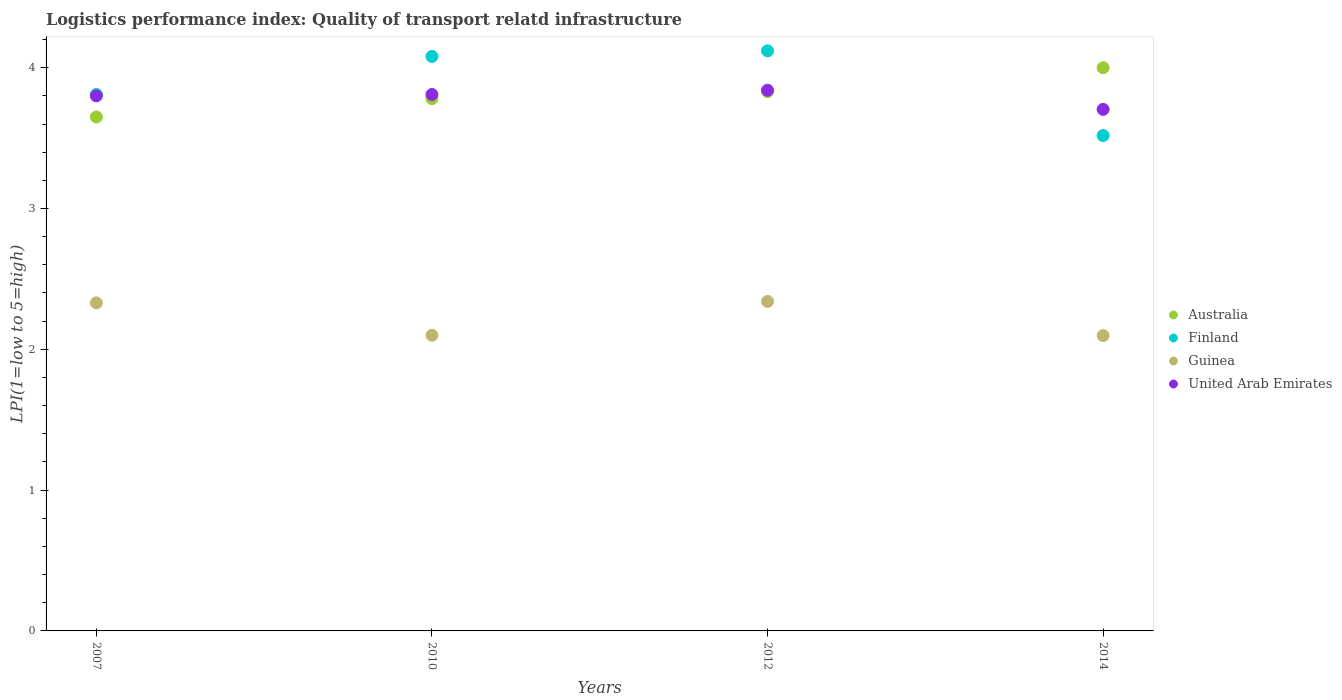What is the logistics performance index in Guinea in 2012?
Give a very brief answer. 2.34. Across all years, what is the maximum logistics performance index in Guinea?
Offer a very short reply. 2.34. Across all years, what is the minimum logistics performance index in Australia?
Ensure brevity in your answer.  3.65. What is the total logistics performance index in Australia in the graph?
Offer a terse response. 15.26. What is the difference between the logistics performance index in Guinea in 2007 and that in 2012?
Offer a terse response. -0.01. What is the difference between the logistics performance index in Finland in 2014 and the logistics performance index in Guinea in 2012?
Your response must be concise. 1.18. What is the average logistics performance index in Finland per year?
Make the answer very short. 3.88. In the year 2010, what is the difference between the logistics performance index in United Arab Emirates and logistics performance index in Australia?
Your answer should be compact. 0.03. In how many years, is the logistics performance index in Guinea greater than 1?
Provide a short and direct response. 4. What is the ratio of the logistics performance index in Guinea in 2010 to that in 2012?
Your response must be concise. 0.9. Is the logistics performance index in Finland in 2007 less than that in 2012?
Offer a very short reply. Yes. Is the difference between the logistics performance index in United Arab Emirates in 2007 and 2010 greater than the difference between the logistics performance index in Australia in 2007 and 2010?
Provide a short and direct response. Yes. What is the difference between the highest and the second highest logistics performance index in Guinea?
Provide a succinct answer. 0.01. What is the difference between the highest and the lowest logistics performance index in Australia?
Ensure brevity in your answer.  0.35. In how many years, is the logistics performance index in United Arab Emirates greater than the average logistics performance index in United Arab Emirates taken over all years?
Make the answer very short. 3. What is the difference between two consecutive major ticks on the Y-axis?
Your answer should be compact. 1. Are the values on the major ticks of Y-axis written in scientific E-notation?
Your response must be concise. No. Does the graph contain grids?
Your answer should be compact. No. How many legend labels are there?
Make the answer very short. 4. How are the legend labels stacked?
Make the answer very short. Vertical. What is the title of the graph?
Your answer should be very brief. Logistics performance index: Quality of transport relatd infrastructure. What is the label or title of the X-axis?
Ensure brevity in your answer.  Years. What is the label or title of the Y-axis?
Your response must be concise. LPI(1=low to 5=high). What is the LPI(1=low to 5=high) in Australia in 2007?
Offer a terse response. 3.65. What is the LPI(1=low to 5=high) of Finland in 2007?
Your answer should be very brief. 3.81. What is the LPI(1=low to 5=high) in Guinea in 2007?
Give a very brief answer. 2.33. What is the LPI(1=low to 5=high) of United Arab Emirates in 2007?
Provide a succinct answer. 3.8. What is the LPI(1=low to 5=high) in Australia in 2010?
Provide a succinct answer. 3.78. What is the LPI(1=low to 5=high) of Finland in 2010?
Offer a very short reply. 4.08. What is the LPI(1=low to 5=high) of Guinea in 2010?
Ensure brevity in your answer.  2.1. What is the LPI(1=low to 5=high) in United Arab Emirates in 2010?
Offer a very short reply. 3.81. What is the LPI(1=low to 5=high) in Australia in 2012?
Make the answer very short. 3.83. What is the LPI(1=low to 5=high) in Finland in 2012?
Your response must be concise. 4.12. What is the LPI(1=low to 5=high) of Guinea in 2012?
Provide a short and direct response. 2.34. What is the LPI(1=low to 5=high) of United Arab Emirates in 2012?
Your answer should be compact. 3.84. What is the LPI(1=low to 5=high) of Australia in 2014?
Ensure brevity in your answer.  4. What is the LPI(1=low to 5=high) in Finland in 2014?
Give a very brief answer. 3.52. What is the LPI(1=low to 5=high) of Guinea in 2014?
Provide a succinct answer. 2.1. What is the LPI(1=low to 5=high) in United Arab Emirates in 2014?
Make the answer very short. 3.7. Across all years, what is the maximum LPI(1=low to 5=high) of Australia?
Keep it short and to the point. 4. Across all years, what is the maximum LPI(1=low to 5=high) of Finland?
Give a very brief answer. 4.12. Across all years, what is the maximum LPI(1=low to 5=high) in Guinea?
Offer a terse response. 2.34. Across all years, what is the maximum LPI(1=low to 5=high) of United Arab Emirates?
Keep it short and to the point. 3.84. Across all years, what is the minimum LPI(1=low to 5=high) of Australia?
Your response must be concise. 3.65. Across all years, what is the minimum LPI(1=low to 5=high) of Finland?
Provide a succinct answer. 3.52. Across all years, what is the minimum LPI(1=low to 5=high) of Guinea?
Your response must be concise. 2.1. Across all years, what is the minimum LPI(1=low to 5=high) in United Arab Emirates?
Provide a succinct answer. 3.7. What is the total LPI(1=low to 5=high) in Australia in the graph?
Offer a terse response. 15.26. What is the total LPI(1=low to 5=high) of Finland in the graph?
Your answer should be very brief. 15.53. What is the total LPI(1=low to 5=high) in Guinea in the graph?
Offer a very short reply. 8.87. What is the total LPI(1=low to 5=high) in United Arab Emirates in the graph?
Offer a terse response. 15.15. What is the difference between the LPI(1=low to 5=high) in Australia in 2007 and that in 2010?
Ensure brevity in your answer.  -0.13. What is the difference between the LPI(1=low to 5=high) in Finland in 2007 and that in 2010?
Offer a terse response. -0.27. What is the difference between the LPI(1=low to 5=high) in Guinea in 2007 and that in 2010?
Your answer should be very brief. 0.23. What is the difference between the LPI(1=low to 5=high) of United Arab Emirates in 2007 and that in 2010?
Make the answer very short. -0.01. What is the difference between the LPI(1=low to 5=high) of Australia in 2007 and that in 2012?
Make the answer very short. -0.18. What is the difference between the LPI(1=low to 5=high) in Finland in 2007 and that in 2012?
Your response must be concise. -0.31. What is the difference between the LPI(1=low to 5=high) of Guinea in 2007 and that in 2012?
Make the answer very short. -0.01. What is the difference between the LPI(1=low to 5=high) of United Arab Emirates in 2007 and that in 2012?
Give a very brief answer. -0.04. What is the difference between the LPI(1=low to 5=high) in Australia in 2007 and that in 2014?
Offer a terse response. -0.35. What is the difference between the LPI(1=low to 5=high) of Finland in 2007 and that in 2014?
Make the answer very short. 0.29. What is the difference between the LPI(1=low to 5=high) in Guinea in 2007 and that in 2014?
Give a very brief answer. 0.23. What is the difference between the LPI(1=low to 5=high) in United Arab Emirates in 2007 and that in 2014?
Keep it short and to the point. 0.1. What is the difference between the LPI(1=low to 5=high) in Australia in 2010 and that in 2012?
Your response must be concise. -0.05. What is the difference between the LPI(1=low to 5=high) of Finland in 2010 and that in 2012?
Offer a terse response. -0.04. What is the difference between the LPI(1=low to 5=high) of Guinea in 2010 and that in 2012?
Offer a terse response. -0.24. What is the difference between the LPI(1=low to 5=high) of United Arab Emirates in 2010 and that in 2012?
Keep it short and to the point. -0.03. What is the difference between the LPI(1=low to 5=high) of Australia in 2010 and that in 2014?
Make the answer very short. -0.22. What is the difference between the LPI(1=low to 5=high) of Finland in 2010 and that in 2014?
Provide a short and direct response. 0.56. What is the difference between the LPI(1=low to 5=high) in Guinea in 2010 and that in 2014?
Your response must be concise. 0. What is the difference between the LPI(1=low to 5=high) of United Arab Emirates in 2010 and that in 2014?
Ensure brevity in your answer.  0.11. What is the difference between the LPI(1=low to 5=high) in Australia in 2012 and that in 2014?
Give a very brief answer. -0.17. What is the difference between the LPI(1=low to 5=high) of Finland in 2012 and that in 2014?
Ensure brevity in your answer.  0.6. What is the difference between the LPI(1=low to 5=high) in Guinea in 2012 and that in 2014?
Offer a terse response. 0.24. What is the difference between the LPI(1=low to 5=high) in United Arab Emirates in 2012 and that in 2014?
Keep it short and to the point. 0.14. What is the difference between the LPI(1=low to 5=high) in Australia in 2007 and the LPI(1=low to 5=high) in Finland in 2010?
Make the answer very short. -0.43. What is the difference between the LPI(1=low to 5=high) in Australia in 2007 and the LPI(1=low to 5=high) in Guinea in 2010?
Make the answer very short. 1.55. What is the difference between the LPI(1=low to 5=high) of Australia in 2007 and the LPI(1=low to 5=high) of United Arab Emirates in 2010?
Give a very brief answer. -0.16. What is the difference between the LPI(1=low to 5=high) of Finland in 2007 and the LPI(1=low to 5=high) of Guinea in 2010?
Provide a succinct answer. 1.71. What is the difference between the LPI(1=low to 5=high) in Guinea in 2007 and the LPI(1=low to 5=high) in United Arab Emirates in 2010?
Ensure brevity in your answer.  -1.48. What is the difference between the LPI(1=low to 5=high) in Australia in 2007 and the LPI(1=low to 5=high) in Finland in 2012?
Your response must be concise. -0.47. What is the difference between the LPI(1=low to 5=high) in Australia in 2007 and the LPI(1=low to 5=high) in Guinea in 2012?
Keep it short and to the point. 1.31. What is the difference between the LPI(1=low to 5=high) of Australia in 2007 and the LPI(1=low to 5=high) of United Arab Emirates in 2012?
Offer a very short reply. -0.19. What is the difference between the LPI(1=low to 5=high) in Finland in 2007 and the LPI(1=low to 5=high) in Guinea in 2012?
Provide a short and direct response. 1.47. What is the difference between the LPI(1=low to 5=high) of Finland in 2007 and the LPI(1=low to 5=high) of United Arab Emirates in 2012?
Make the answer very short. -0.03. What is the difference between the LPI(1=low to 5=high) of Guinea in 2007 and the LPI(1=low to 5=high) of United Arab Emirates in 2012?
Keep it short and to the point. -1.51. What is the difference between the LPI(1=low to 5=high) of Australia in 2007 and the LPI(1=low to 5=high) of Finland in 2014?
Provide a succinct answer. 0.13. What is the difference between the LPI(1=low to 5=high) of Australia in 2007 and the LPI(1=low to 5=high) of Guinea in 2014?
Give a very brief answer. 1.55. What is the difference between the LPI(1=low to 5=high) of Australia in 2007 and the LPI(1=low to 5=high) of United Arab Emirates in 2014?
Keep it short and to the point. -0.05. What is the difference between the LPI(1=low to 5=high) in Finland in 2007 and the LPI(1=low to 5=high) in Guinea in 2014?
Your answer should be very brief. 1.71. What is the difference between the LPI(1=low to 5=high) of Finland in 2007 and the LPI(1=low to 5=high) of United Arab Emirates in 2014?
Offer a terse response. 0.11. What is the difference between the LPI(1=low to 5=high) in Guinea in 2007 and the LPI(1=low to 5=high) in United Arab Emirates in 2014?
Offer a very short reply. -1.37. What is the difference between the LPI(1=low to 5=high) of Australia in 2010 and the LPI(1=low to 5=high) of Finland in 2012?
Your answer should be very brief. -0.34. What is the difference between the LPI(1=low to 5=high) in Australia in 2010 and the LPI(1=low to 5=high) in Guinea in 2012?
Your response must be concise. 1.44. What is the difference between the LPI(1=low to 5=high) in Australia in 2010 and the LPI(1=low to 5=high) in United Arab Emirates in 2012?
Your answer should be very brief. -0.06. What is the difference between the LPI(1=low to 5=high) in Finland in 2010 and the LPI(1=low to 5=high) in Guinea in 2012?
Offer a very short reply. 1.74. What is the difference between the LPI(1=low to 5=high) in Finland in 2010 and the LPI(1=low to 5=high) in United Arab Emirates in 2012?
Make the answer very short. 0.24. What is the difference between the LPI(1=low to 5=high) in Guinea in 2010 and the LPI(1=low to 5=high) in United Arab Emirates in 2012?
Your answer should be compact. -1.74. What is the difference between the LPI(1=low to 5=high) in Australia in 2010 and the LPI(1=low to 5=high) in Finland in 2014?
Provide a succinct answer. 0.26. What is the difference between the LPI(1=low to 5=high) of Australia in 2010 and the LPI(1=low to 5=high) of Guinea in 2014?
Keep it short and to the point. 1.68. What is the difference between the LPI(1=low to 5=high) of Australia in 2010 and the LPI(1=low to 5=high) of United Arab Emirates in 2014?
Provide a succinct answer. 0.08. What is the difference between the LPI(1=low to 5=high) in Finland in 2010 and the LPI(1=low to 5=high) in Guinea in 2014?
Offer a very short reply. 1.98. What is the difference between the LPI(1=low to 5=high) of Finland in 2010 and the LPI(1=low to 5=high) of United Arab Emirates in 2014?
Ensure brevity in your answer.  0.38. What is the difference between the LPI(1=low to 5=high) of Guinea in 2010 and the LPI(1=low to 5=high) of United Arab Emirates in 2014?
Your response must be concise. -1.6. What is the difference between the LPI(1=low to 5=high) in Australia in 2012 and the LPI(1=low to 5=high) in Finland in 2014?
Your response must be concise. 0.31. What is the difference between the LPI(1=low to 5=high) in Australia in 2012 and the LPI(1=low to 5=high) in Guinea in 2014?
Offer a terse response. 1.73. What is the difference between the LPI(1=low to 5=high) of Australia in 2012 and the LPI(1=low to 5=high) of United Arab Emirates in 2014?
Your answer should be compact. 0.13. What is the difference between the LPI(1=low to 5=high) of Finland in 2012 and the LPI(1=low to 5=high) of Guinea in 2014?
Give a very brief answer. 2.02. What is the difference between the LPI(1=low to 5=high) of Finland in 2012 and the LPI(1=low to 5=high) of United Arab Emirates in 2014?
Provide a succinct answer. 0.42. What is the difference between the LPI(1=low to 5=high) of Guinea in 2012 and the LPI(1=low to 5=high) of United Arab Emirates in 2014?
Give a very brief answer. -1.36. What is the average LPI(1=low to 5=high) in Australia per year?
Your answer should be compact. 3.81. What is the average LPI(1=low to 5=high) of Finland per year?
Provide a short and direct response. 3.88. What is the average LPI(1=low to 5=high) in Guinea per year?
Make the answer very short. 2.22. What is the average LPI(1=low to 5=high) of United Arab Emirates per year?
Your answer should be very brief. 3.79. In the year 2007, what is the difference between the LPI(1=low to 5=high) in Australia and LPI(1=low to 5=high) in Finland?
Your response must be concise. -0.16. In the year 2007, what is the difference between the LPI(1=low to 5=high) in Australia and LPI(1=low to 5=high) in Guinea?
Make the answer very short. 1.32. In the year 2007, what is the difference between the LPI(1=low to 5=high) in Australia and LPI(1=low to 5=high) in United Arab Emirates?
Offer a terse response. -0.15. In the year 2007, what is the difference between the LPI(1=low to 5=high) in Finland and LPI(1=low to 5=high) in Guinea?
Give a very brief answer. 1.48. In the year 2007, what is the difference between the LPI(1=low to 5=high) in Guinea and LPI(1=low to 5=high) in United Arab Emirates?
Offer a very short reply. -1.47. In the year 2010, what is the difference between the LPI(1=low to 5=high) of Australia and LPI(1=low to 5=high) of Finland?
Keep it short and to the point. -0.3. In the year 2010, what is the difference between the LPI(1=low to 5=high) of Australia and LPI(1=low to 5=high) of Guinea?
Your response must be concise. 1.68. In the year 2010, what is the difference between the LPI(1=low to 5=high) in Australia and LPI(1=low to 5=high) in United Arab Emirates?
Your answer should be compact. -0.03. In the year 2010, what is the difference between the LPI(1=low to 5=high) of Finland and LPI(1=low to 5=high) of Guinea?
Give a very brief answer. 1.98. In the year 2010, what is the difference between the LPI(1=low to 5=high) in Finland and LPI(1=low to 5=high) in United Arab Emirates?
Your answer should be very brief. 0.27. In the year 2010, what is the difference between the LPI(1=low to 5=high) of Guinea and LPI(1=low to 5=high) of United Arab Emirates?
Your answer should be very brief. -1.71. In the year 2012, what is the difference between the LPI(1=low to 5=high) of Australia and LPI(1=low to 5=high) of Finland?
Keep it short and to the point. -0.29. In the year 2012, what is the difference between the LPI(1=low to 5=high) of Australia and LPI(1=low to 5=high) of Guinea?
Provide a succinct answer. 1.49. In the year 2012, what is the difference between the LPI(1=low to 5=high) in Australia and LPI(1=low to 5=high) in United Arab Emirates?
Offer a very short reply. -0.01. In the year 2012, what is the difference between the LPI(1=low to 5=high) of Finland and LPI(1=low to 5=high) of Guinea?
Give a very brief answer. 1.78. In the year 2012, what is the difference between the LPI(1=low to 5=high) of Finland and LPI(1=low to 5=high) of United Arab Emirates?
Your answer should be very brief. 0.28. In the year 2012, what is the difference between the LPI(1=low to 5=high) of Guinea and LPI(1=low to 5=high) of United Arab Emirates?
Offer a terse response. -1.5. In the year 2014, what is the difference between the LPI(1=low to 5=high) of Australia and LPI(1=low to 5=high) of Finland?
Give a very brief answer. 0.48. In the year 2014, what is the difference between the LPI(1=low to 5=high) of Australia and LPI(1=low to 5=high) of Guinea?
Make the answer very short. 1.9. In the year 2014, what is the difference between the LPI(1=low to 5=high) in Australia and LPI(1=low to 5=high) in United Arab Emirates?
Provide a short and direct response. 0.3. In the year 2014, what is the difference between the LPI(1=low to 5=high) in Finland and LPI(1=low to 5=high) in Guinea?
Offer a terse response. 1.42. In the year 2014, what is the difference between the LPI(1=low to 5=high) in Finland and LPI(1=low to 5=high) in United Arab Emirates?
Provide a short and direct response. -0.19. In the year 2014, what is the difference between the LPI(1=low to 5=high) in Guinea and LPI(1=low to 5=high) in United Arab Emirates?
Your response must be concise. -1.61. What is the ratio of the LPI(1=low to 5=high) of Australia in 2007 to that in 2010?
Give a very brief answer. 0.97. What is the ratio of the LPI(1=low to 5=high) in Finland in 2007 to that in 2010?
Ensure brevity in your answer.  0.93. What is the ratio of the LPI(1=low to 5=high) of Guinea in 2007 to that in 2010?
Your answer should be compact. 1.11. What is the ratio of the LPI(1=low to 5=high) in Australia in 2007 to that in 2012?
Your answer should be very brief. 0.95. What is the ratio of the LPI(1=low to 5=high) in Finland in 2007 to that in 2012?
Your answer should be compact. 0.92. What is the ratio of the LPI(1=low to 5=high) of United Arab Emirates in 2007 to that in 2012?
Your response must be concise. 0.99. What is the ratio of the LPI(1=low to 5=high) of Australia in 2007 to that in 2014?
Keep it short and to the point. 0.91. What is the ratio of the LPI(1=low to 5=high) in Finland in 2007 to that in 2014?
Your answer should be compact. 1.08. What is the ratio of the LPI(1=low to 5=high) in Guinea in 2007 to that in 2014?
Keep it short and to the point. 1.11. What is the ratio of the LPI(1=low to 5=high) in United Arab Emirates in 2007 to that in 2014?
Provide a succinct answer. 1.03. What is the ratio of the LPI(1=low to 5=high) of Australia in 2010 to that in 2012?
Offer a terse response. 0.99. What is the ratio of the LPI(1=low to 5=high) of Finland in 2010 to that in 2012?
Ensure brevity in your answer.  0.99. What is the ratio of the LPI(1=low to 5=high) in Guinea in 2010 to that in 2012?
Provide a short and direct response. 0.9. What is the ratio of the LPI(1=low to 5=high) in Australia in 2010 to that in 2014?
Your answer should be very brief. 0.94. What is the ratio of the LPI(1=low to 5=high) of Finland in 2010 to that in 2014?
Your answer should be compact. 1.16. What is the ratio of the LPI(1=low to 5=high) in Guinea in 2010 to that in 2014?
Make the answer very short. 1. What is the ratio of the LPI(1=low to 5=high) in United Arab Emirates in 2010 to that in 2014?
Your response must be concise. 1.03. What is the ratio of the LPI(1=low to 5=high) of Australia in 2012 to that in 2014?
Make the answer very short. 0.96. What is the ratio of the LPI(1=low to 5=high) in Finland in 2012 to that in 2014?
Ensure brevity in your answer.  1.17. What is the ratio of the LPI(1=low to 5=high) of Guinea in 2012 to that in 2014?
Offer a terse response. 1.12. What is the ratio of the LPI(1=low to 5=high) of United Arab Emirates in 2012 to that in 2014?
Offer a terse response. 1.04. What is the difference between the highest and the second highest LPI(1=low to 5=high) in Australia?
Provide a succinct answer. 0.17. What is the difference between the highest and the second highest LPI(1=low to 5=high) of Finland?
Offer a terse response. 0.04. What is the difference between the highest and the second highest LPI(1=low to 5=high) of United Arab Emirates?
Keep it short and to the point. 0.03. What is the difference between the highest and the lowest LPI(1=low to 5=high) of Finland?
Your answer should be compact. 0.6. What is the difference between the highest and the lowest LPI(1=low to 5=high) in Guinea?
Keep it short and to the point. 0.24. What is the difference between the highest and the lowest LPI(1=low to 5=high) in United Arab Emirates?
Keep it short and to the point. 0.14. 